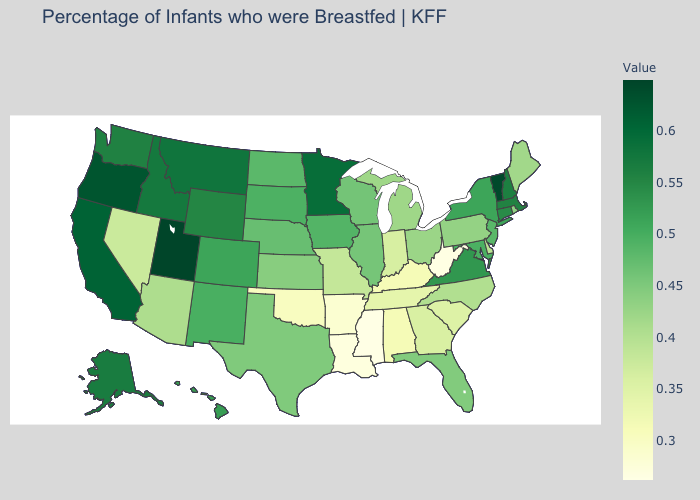Which states hav the highest value in the South?
Concise answer only. Virginia. Does Michigan have a lower value than West Virginia?
Give a very brief answer. No. Is the legend a continuous bar?
Be succinct. Yes. Does Wisconsin have the lowest value in the MidWest?
Quick response, please. No. 